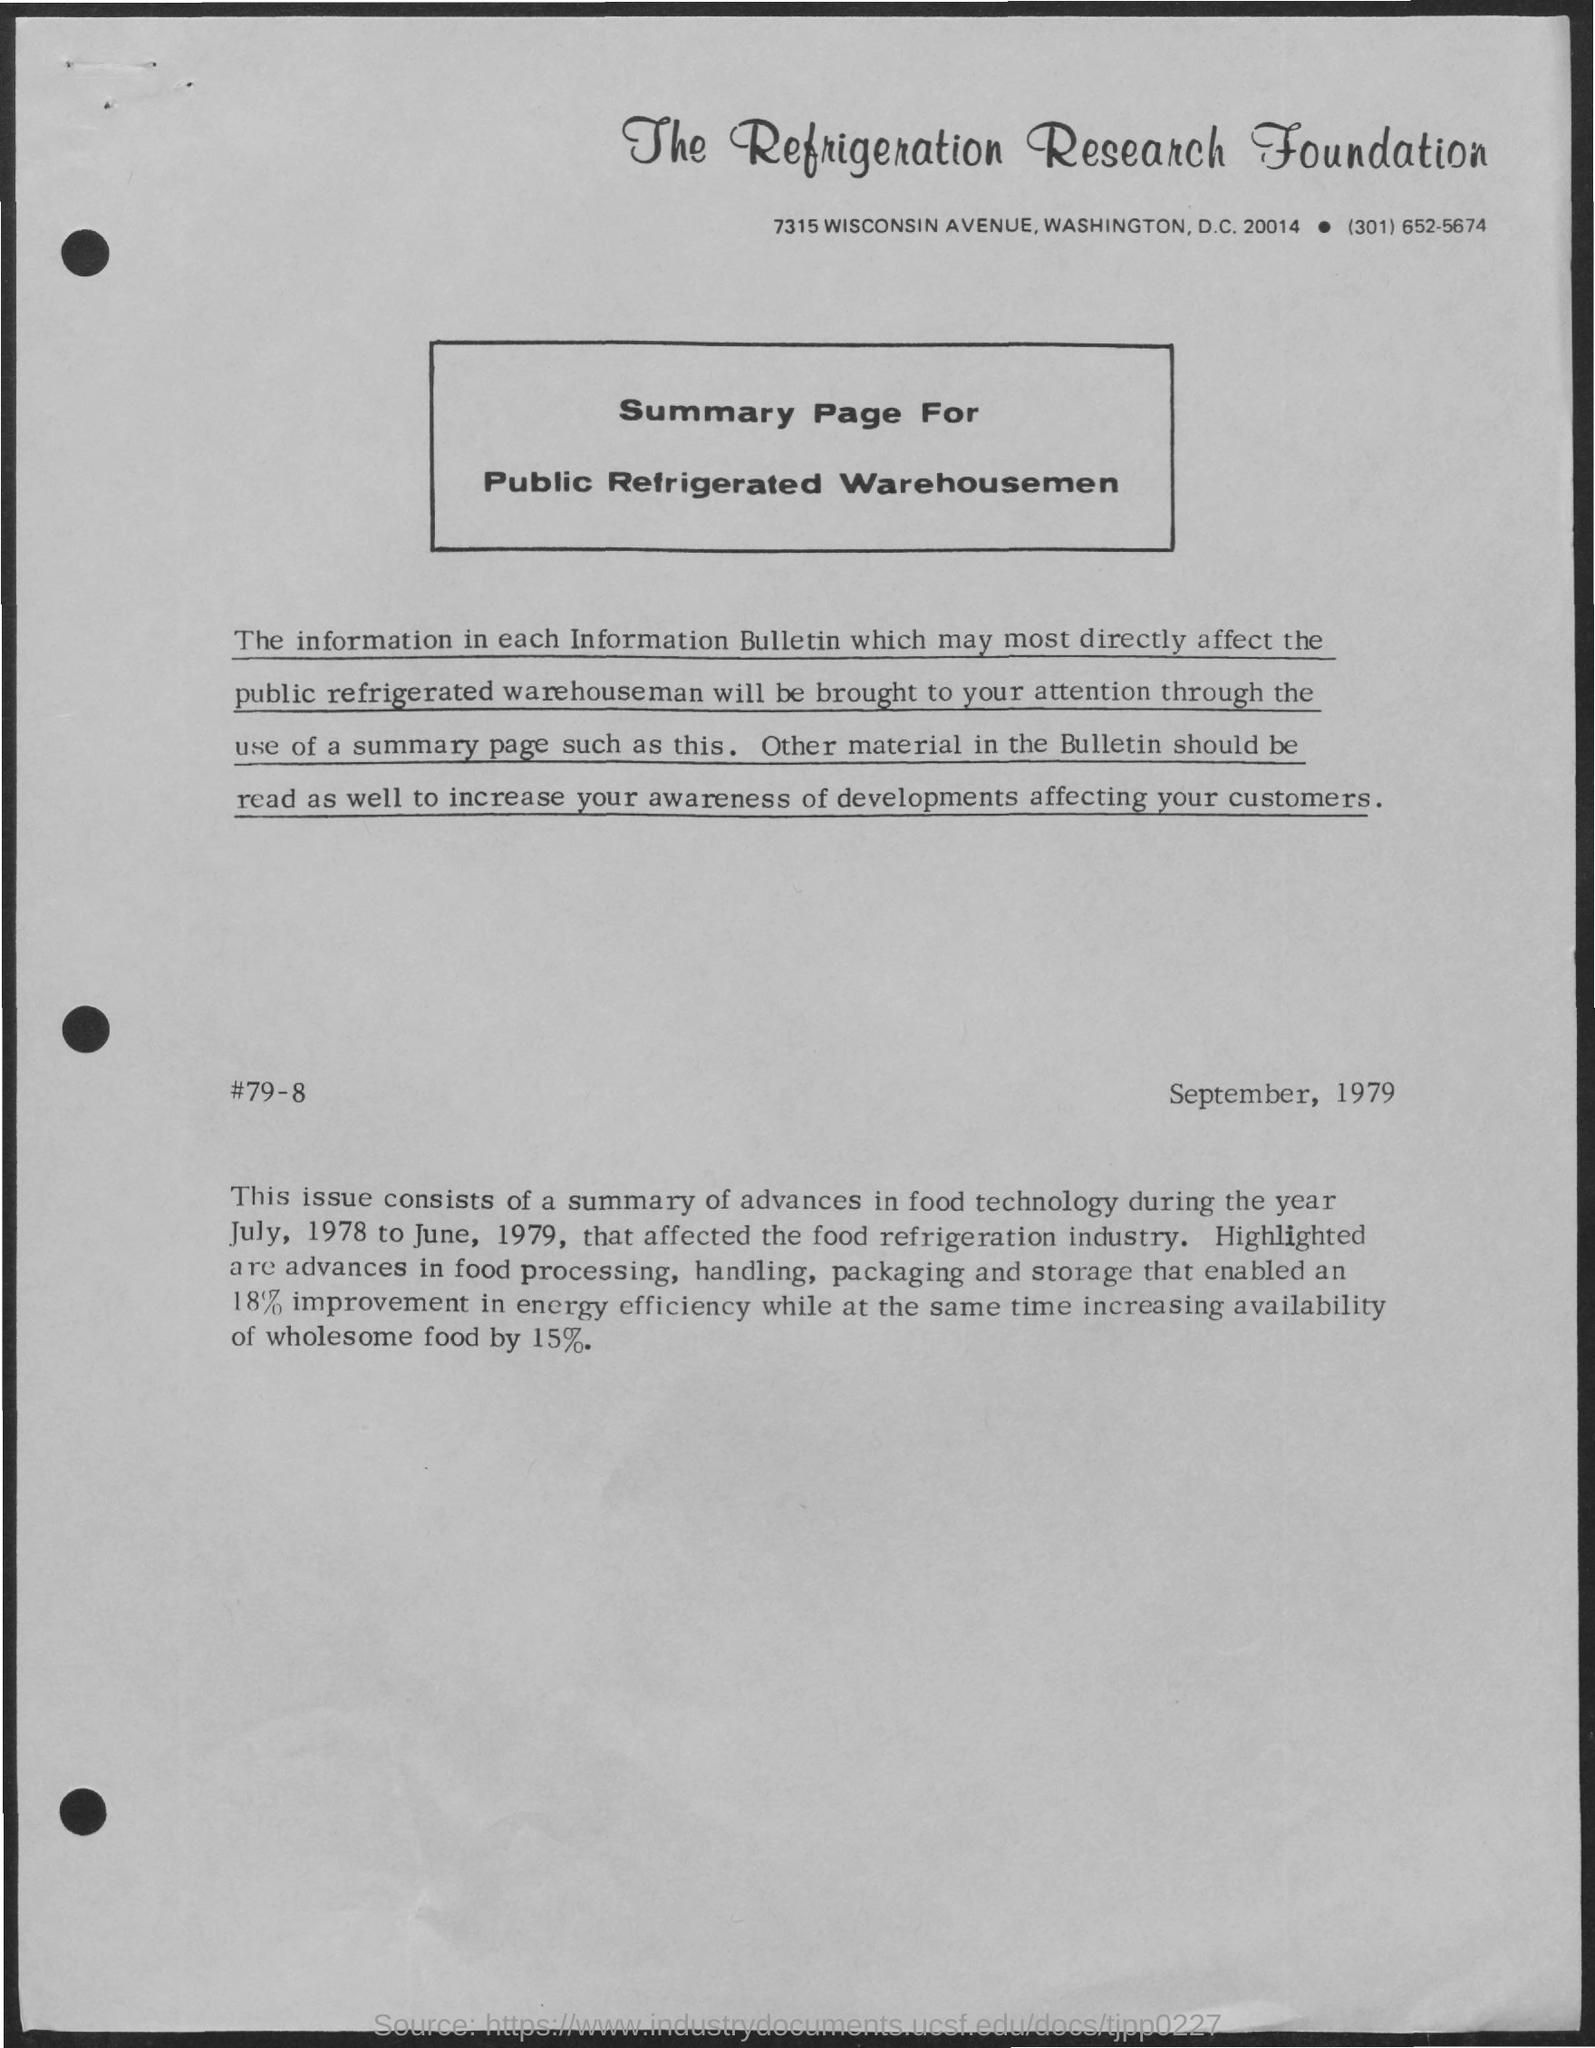What is the title of the document?
Provide a short and direct response. The refrigeration research foundation. What is written inside the box?
Your answer should be compact. Summary page for public refrigerated warehousemen. 